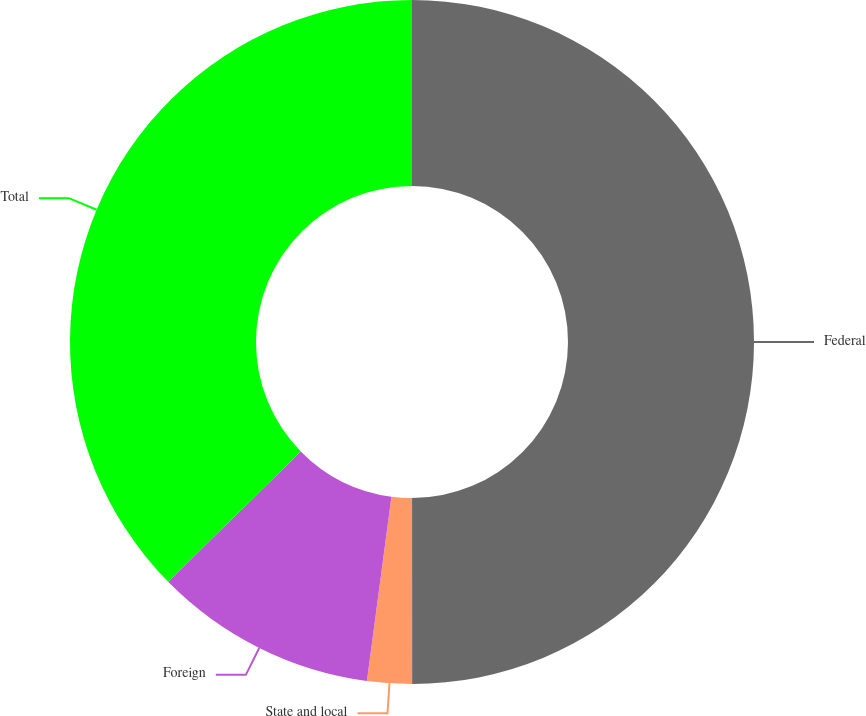Convert chart to OTSL. <chart><loc_0><loc_0><loc_500><loc_500><pie_chart><fcel>Federal<fcel>State and local<fcel>Foreign<fcel>Total<nl><fcel>50.0%<fcel>2.11%<fcel>10.53%<fcel>37.37%<nl></chart> 